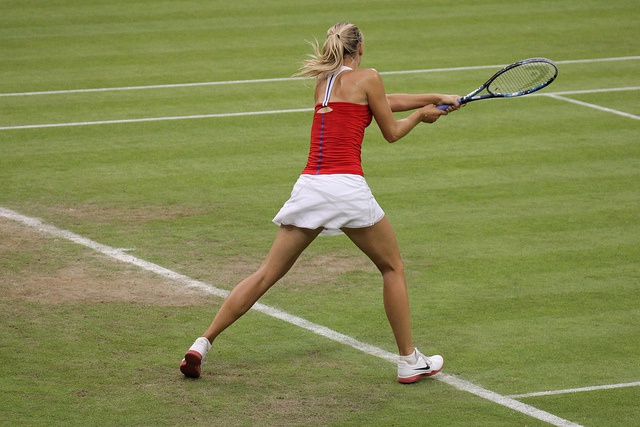Describe the objects in this image and their specific colors. I can see people in olive, lavender, gray, tan, and maroon tones and tennis racket in olive, gray, black, and darkgray tones in this image. 